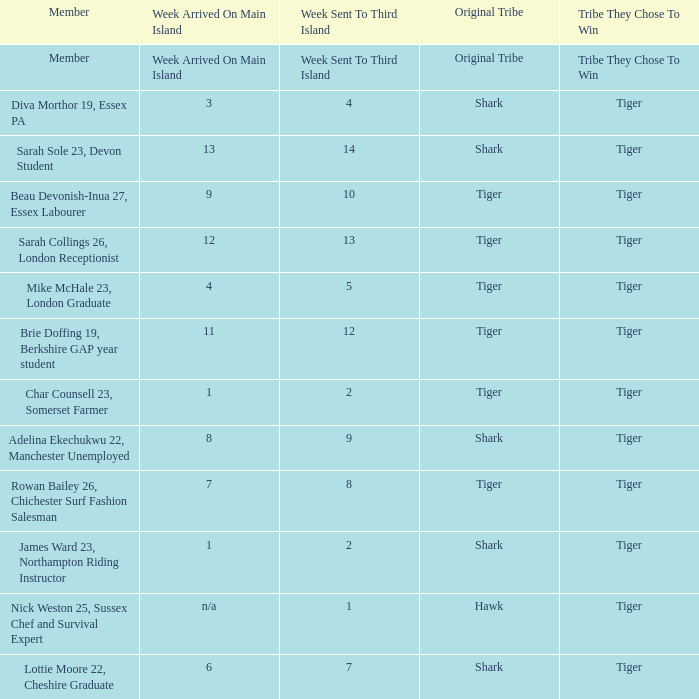What week did the member who's original tribe was shark and who was sent to the third island on week 14 arrive on the main island? 13.0. 